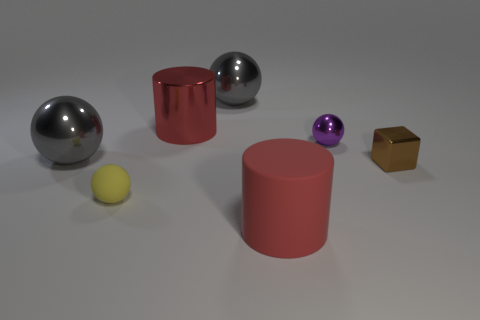There is a thing that is the same color as the big matte cylinder; what is its material?
Provide a succinct answer. Metal. Does the large object that is in front of the tiny yellow object have the same material as the red object that is on the left side of the large rubber cylinder?
Your answer should be compact. No. Are there any other things that are the same color as the metal block?
Provide a short and direct response. No. The other tiny thing that is the same shape as the purple object is what color?
Your answer should be compact. Yellow. How big is the ball that is on the right side of the yellow rubber thing and in front of the red metal cylinder?
Keep it short and to the point. Small. There is a large red object that is behind the yellow thing; is its shape the same as the large gray metallic thing that is on the left side of the large red shiny cylinder?
Your response must be concise. No. There is another object that is the same color as the large matte object; what is its shape?
Your answer should be very brief. Cylinder. How many other large balls are the same material as the yellow sphere?
Make the answer very short. 0. What is the shape of the object that is both on the right side of the rubber sphere and in front of the small brown shiny cube?
Provide a short and direct response. Cylinder. Are the large cylinder behind the rubber cylinder and the yellow object made of the same material?
Make the answer very short. No. 